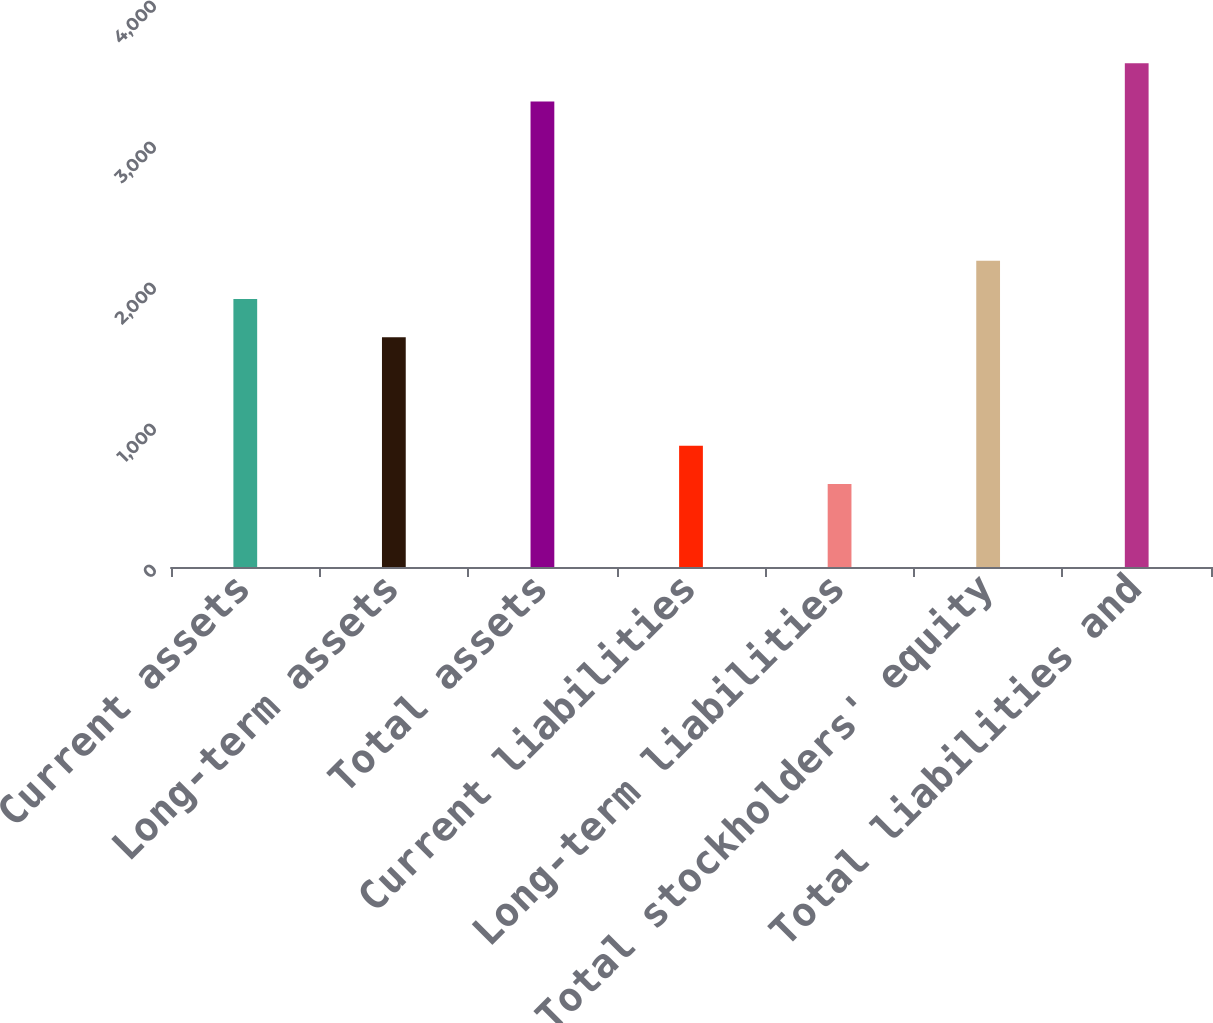<chart> <loc_0><loc_0><loc_500><loc_500><bar_chart><fcel>Current assets<fcel>Long-term assets<fcel>Total assets<fcel>Current liabilities<fcel>Long-term liabilities<fcel>Total stockholders' equity<fcel>Total liabilities and<nl><fcel>1900.3<fcel>1629<fcel>3302<fcel>860.3<fcel>589<fcel>2171.6<fcel>3573.3<nl></chart> 